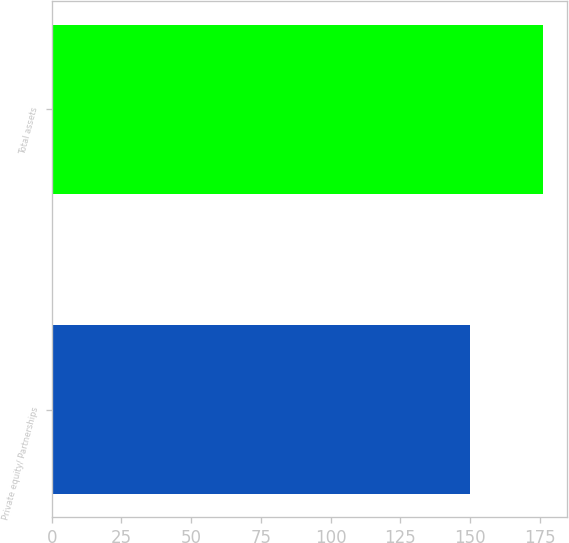Convert chart to OTSL. <chart><loc_0><loc_0><loc_500><loc_500><bar_chart><fcel>Private equity/ Partnerships<fcel>Total assets<nl><fcel>150<fcel>176<nl></chart> 